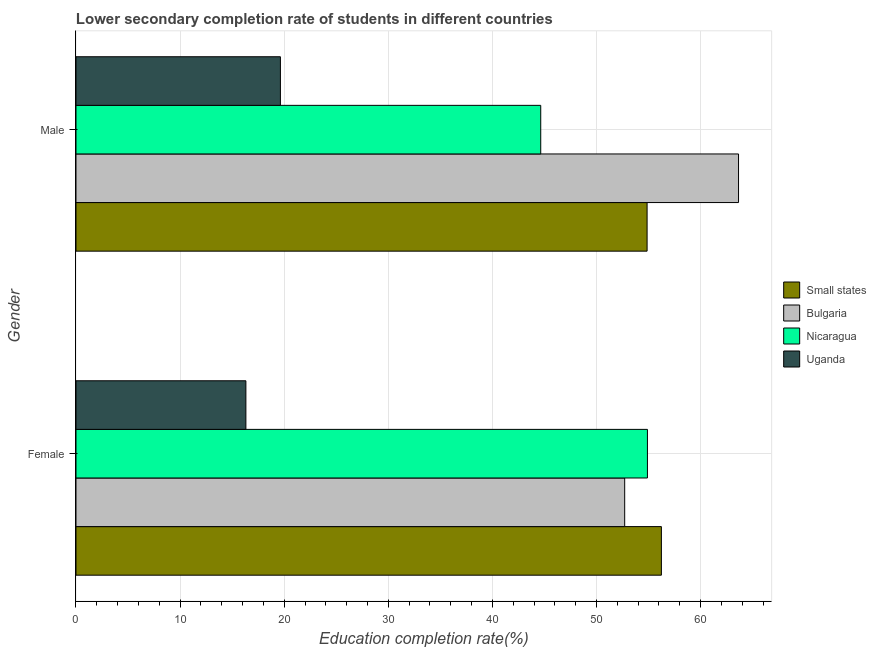How many different coloured bars are there?
Offer a very short reply. 4. How many groups of bars are there?
Give a very brief answer. 2. Are the number of bars per tick equal to the number of legend labels?
Your answer should be compact. Yes. Are the number of bars on each tick of the Y-axis equal?
Give a very brief answer. Yes. What is the label of the 2nd group of bars from the top?
Make the answer very short. Female. What is the education completion rate of female students in Nicaragua?
Give a very brief answer. 54.9. Across all countries, what is the maximum education completion rate of male students?
Ensure brevity in your answer.  63.65. Across all countries, what is the minimum education completion rate of male students?
Your answer should be very brief. 19.64. In which country was the education completion rate of female students maximum?
Make the answer very short. Small states. In which country was the education completion rate of female students minimum?
Ensure brevity in your answer.  Uganda. What is the total education completion rate of male students in the graph?
Your answer should be very brief. 182.79. What is the difference between the education completion rate of male students in Small states and that in Uganda?
Your answer should be very brief. 35.22. What is the difference between the education completion rate of male students in Bulgaria and the education completion rate of female students in Uganda?
Ensure brevity in your answer.  47.33. What is the average education completion rate of female students per country?
Your answer should be very brief. 45.04. What is the difference between the education completion rate of male students and education completion rate of female students in Uganda?
Your answer should be compact. 3.32. What is the ratio of the education completion rate of male students in Nicaragua to that in Small states?
Your response must be concise. 0.81. Is the education completion rate of female students in Nicaragua less than that in Uganda?
Keep it short and to the point. No. In how many countries, is the education completion rate of female students greater than the average education completion rate of female students taken over all countries?
Provide a succinct answer. 3. What does the 2nd bar from the top in Male represents?
Offer a terse response. Nicaragua. What does the 1st bar from the bottom in Female represents?
Offer a very short reply. Small states. How many bars are there?
Your answer should be very brief. 8. Are all the bars in the graph horizontal?
Provide a succinct answer. Yes. How many countries are there in the graph?
Keep it short and to the point. 4. What is the difference between two consecutive major ticks on the X-axis?
Make the answer very short. 10. Does the graph contain any zero values?
Your answer should be very brief. No. Where does the legend appear in the graph?
Offer a very short reply. Center right. How many legend labels are there?
Your response must be concise. 4. What is the title of the graph?
Provide a short and direct response. Lower secondary completion rate of students in different countries. What is the label or title of the X-axis?
Provide a succinct answer. Education completion rate(%). What is the label or title of the Y-axis?
Your response must be concise. Gender. What is the Education completion rate(%) of Small states in Female?
Ensure brevity in your answer.  56.24. What is the Education completion rate(%) in Bulgaria in Female?
Provide a succinct answer. 52.71. What is the Education completion rate(%) of Nicaragua in Female?
Your answer should be very brief. 54.9. What is the Education completion rate(%) in Uganda in Female?
Your answer should be very brief. 16.32. What is the Education completion rate(%) in Small states in Male?
Provide a short and direct response. 54.86. What is the Education completion rate(%) in Bulgaria in Male?
Your response must be concise. 63.65. What is the Education completion rate(%) in Nicaragua in Male?
Your answer should be compact. 44.65. What is the Education completion rate(%) in Uganda in Male?
Your answer should be very brief. 19.64. Across all Gender, what is the maximum Education completion rate(%) of Small states?
Ensure brevity in your answer.  56.24. Across all Gender, what is the maximum Education completion rate(%) in Bulgaria?
Provide a succinct answer. 63.65. Across all Gender, what is the maximum Education completion rate(%) of Nicaragua?
Make the answer very short. 54.9. Across all Gender, what is the maximum Education completion rate(%) of Uganda?
Make the answer very short. 19.64. Across all Gender, what is the minimum Education completion rate(%) in Small states?
Provide a succinct answer. 54.86. Across all Gender, what is the minimum Education completion rate(%) in Bulgaria?
Your answer should be very brief. 52.71. Across all Gender, what is the minimum Education completion rate(%) in Nicaragua?
Provide a succinct answer. 44.65. Across all Gender, what is the minimum Education completion rate(%) in Uganda?
Offer a very short reply. 16.32. What is the total Education completion rate(%) of Small states in the graph?
Your answer should be very brief. 111.1. What is the total Education completion rate(%) in Bulgaria in the graph?
Your response must be concise. 116.36. What is the total Education completion rate(%) of Nicaragua in the graph?
Offer a terse response. 99.54. What is the total Education completion rate(%) of Uganda in the graph?
Provide a succinct answer. 35.96. What is the difference between the Education completion rate(%) in Small states in Female and that in Male?
Ensure brevity in your answer.  1.37. What is the difference between the Education completion rate(%) in Bulgaria in Female and that in Male?
Give a very brief answer. -10.94. What is the difference between the Education completion rate(%) of Nicaragua in Female and that in Male?
Make the answer very short. 10.25. What is the difference between the Education completion rate(%) of Uganda in Female and that in Male?
Provide a short and direct response. -3.32. What is the difference between the Education completion rate(%) of Small states in Female and the Education completion rate(%) of Bulgaria in Male?
Your response must be concise. -7.41. What is the difference between the Education completion rate(%) of Small states in Female and the Education completion rate(%) of Nicaragua in Male?
Your answer should be compact. 11.59. What is the difference between the Education completion rate(%) of Small states in Female and the Education completion rate(%) of Uganda in Male?
Provide a short and direct response. 36.6. What is the difference between the Education completion rate(%) in Bulgaria in Female and the Education completion rate(%) in Nicaragua in Male?
Provide a short and direct response. 8.06. What is the difference between the Education completion rate(%) in Bulgaria in Female and the Education completion rate(%) in Uganda in Male?
Your answer should be compact. 33.07. What is the difference between the Education completion rate(%) of Nicaragua in Female and the Education completion rate(%) of Uganda in Male?
Ensure brevity in your answer.  35.26. What is the average Education completion rate(%) in Small states per Gender?
Ensure brevity in your answer.  55.55. What is the average Education completion rate(%) in Bulgaria per Gender?
Keep it short and to the point. 58.18. What is the average Education completion rate(%) of Nicaragua per Gender?
Your response must be concise. 49.77. What is the average Education completion rate(%) of Uganda per Gender?
Your answer should be very brief. 17.98. What is the difference between the Education completion rate(%) of Small states and Education completion rate(%) of Bulgaria in Female?
Keep it short and to the point. 3.53. What is the difference between the Education completion rate(%) in Small states and Education completion rate(%) in Nicaragua in Female?
Your response must be concise. 1.34. What is the difference between the Education completion rate(%) of Small states and Education completion rate(%) of Uganda in Female?
Your answer should be compact. 39.91. What is the difference between the Education completion rate(%) of Bulgaria and Education completion rate(%) of Nicaragua in Female?
Offer a terse response. -2.19. What is the difference between the Education completion rate(%) of Bulgaria and Education completion rate(%) of Uganda in Female?
Your answer should be very brief. 36.39. What is the difference between the Education completion rate(%) of Nicaragua and Education completion rate(%) of Uganda in Female?
Offer a terse response. 38.57. What is the difference between the Education completion rate(%) of Small states and Education completion rate(%) of Bulgaria in Male?
Your answer should be compact. -8.78. What is the difference between the Education completion rate(%) of Small states and Education completion rate(%) of Nicaragua in Male?
Keep it short and to the point. 10.22. What is the difference between the Education completion rate(%) of Small states and Education completion rate(%) of Uganda in Male?
Make the answer very short. 35.22. What is the difference between the Education completion rate(%) of Bulgaria and Education completion rate(%) of Nicaragua in Male?
Make the answer very short. 19. What is the difference between the Education completion rate(%) of Bulgaria and Education completion rate(%) of Uganda in Male?
Your answer should be very brief. 44.01. What is the difference between the Education completion rate(%) of Nicaragua and Education completion rate(%) of Uganda in Male?
Offer a terse response. 25.01. What is the ratio of the Education completion rate(%) in Small states in Female to that in Male?
Offer a terse response. 1.02. What is the ratio of the Education completion rate(%) in Bulgaria in Female to that in Male?
Ensure brevity in your answer.  0.83. What is the ratio of the Education completion rate(%) in Nicaragua in Female to that in Male?
Your response must be concise. 1.23. What is the ratio of the Education completion rate(%) of Uganda in Female to that in Male?
Provide a succinct answer. 0.83. What is the difference between the highest and the second highest Education completion rate(%) of Small states?
Provide a succinct answer. 1.37. What is the difference between the highest and the second highest Education completion rate(%) in Bulgaria?
Provide a succinct answer. 10.94. What is the difference between the highest and the second highest Education completion rate(%) of Nicaragua?
Your answer should be very brief. 10.25. What is the difference between the highest and the second highest Education completion rate(%) in Uganda?
Ensure brevity in your answer.  3.32. What is the difference between the highest and the lowest Education completion rate(%) of Small states?
Provide a short and direct response. 1.37. What is the difference between the highest and the lowest Education completion rate(%) of Bulgaria?
Provide a short and direct response. 10.94. What is the difference between the highest and the lowest Education completion rate(%) in Nicaragua?
Your answer should be very brief. 10.25. What is the difference between the highest and the lowest Education completion rate(%) of Uganda?
Your answer should be compact. 3.32. 